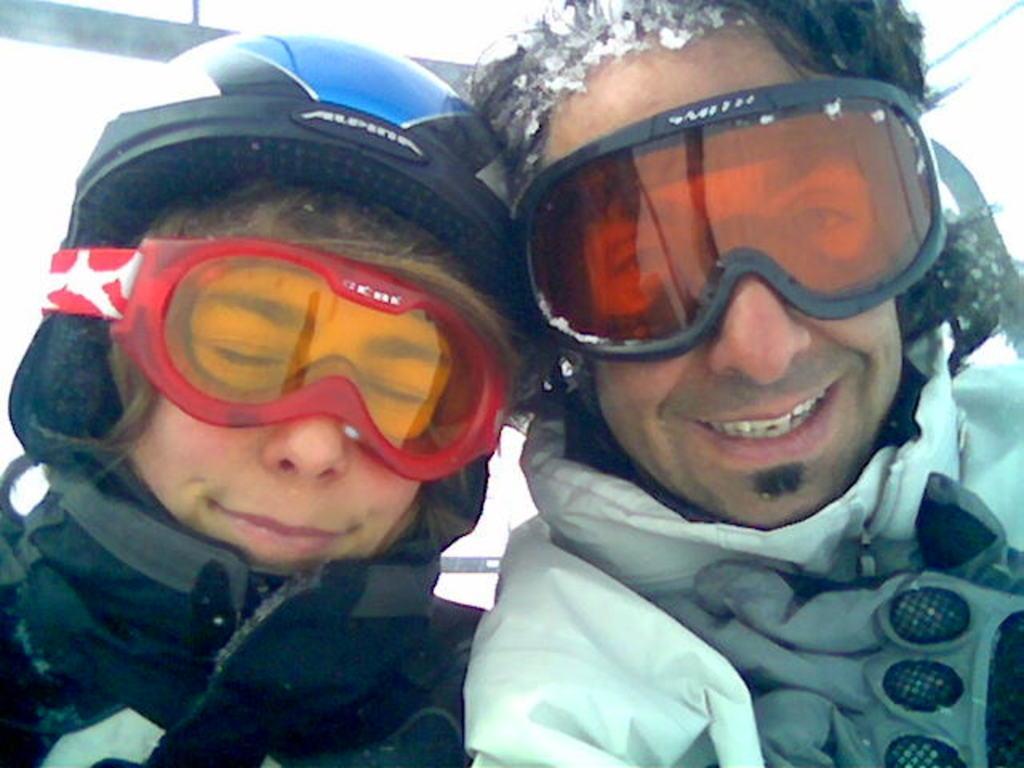How would you summarize this image in a sentence or two? This image consists of persons in the center wearing a winter clothes and having smile on their faces. 